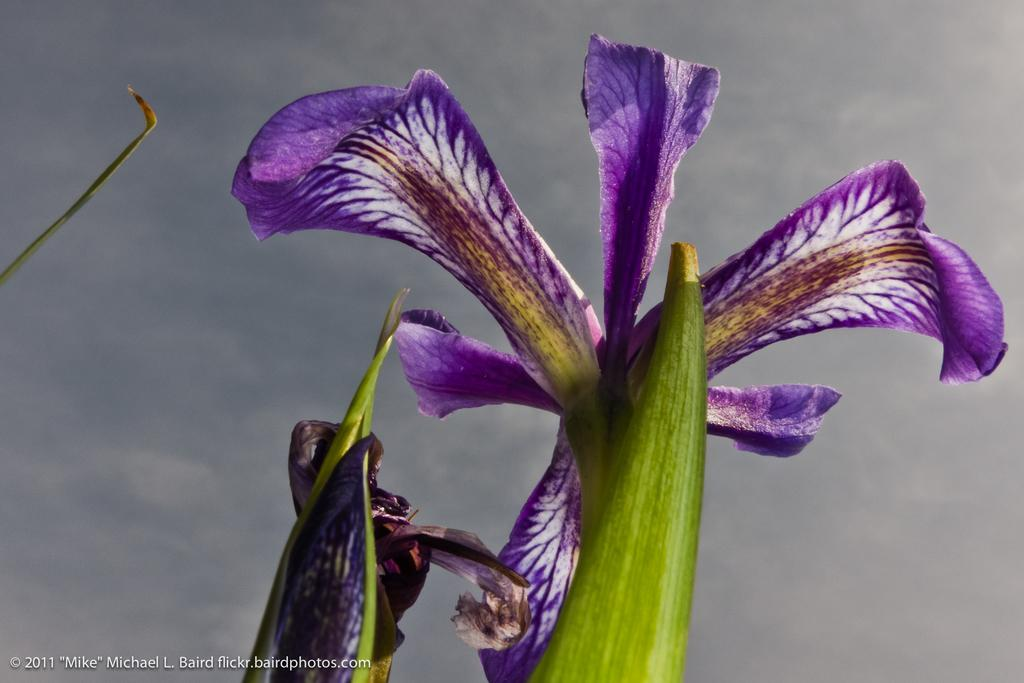What type of plants can be seen in the image? The image contains flowers. What can be seen in the background of the image? The sky is visible in the background of the image. How would you describe the sky in the image? The sky is cloudy in the image. Is there any text present in the image? Yes, there is text at the bottom of the image. What suggestion is being made by the crib in the image? There is no crib present in the image, so no suggestion can be made by it. 